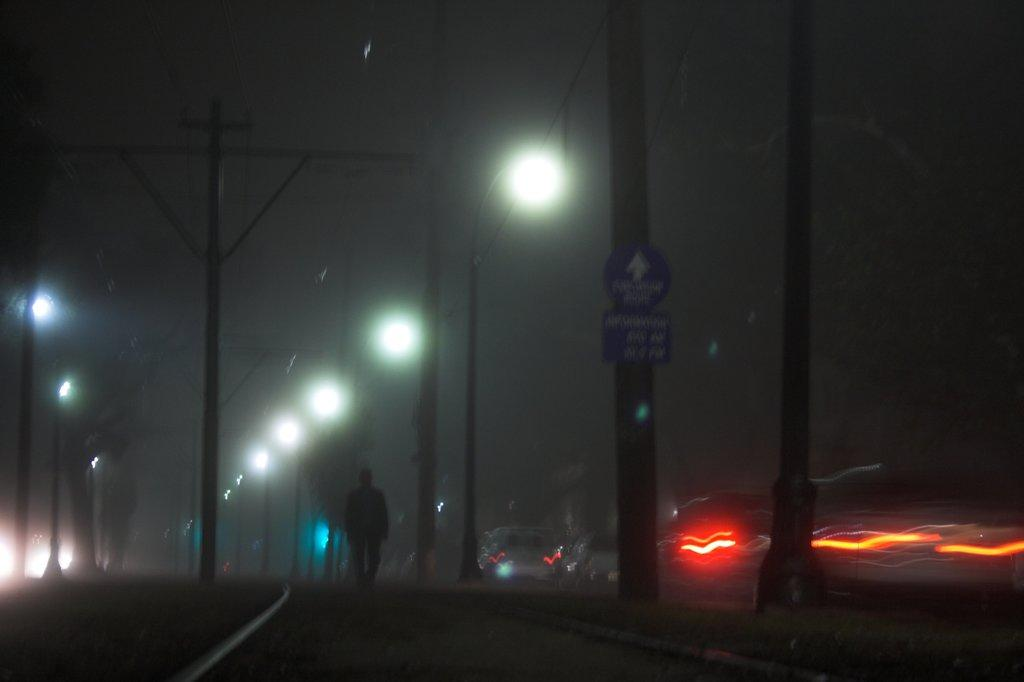What is the person in the image doing? There is a person walking in the image. Where are the lights located in the image? There are lights on both the right and left sides of the image. How would you describe the overall lighting in the image? The image appears to be dark. What reason does the person have for walking in the image? There is no information provided about the person's reason for walking in the image. What type of shoes is the person wearing in the image? The image does not show the person's feet or shoes. 